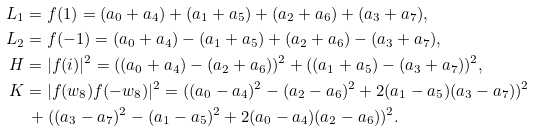Convert formula to latex. <formula><loc_0><loc_0><loc_500><loc_500>L _ { 1 } & = f ( 1 ) = ( a _ { 0 } + a _ { 4 } ) + ( a _ { 1 } + a _ { 5 } ) + ( a _ { 2 } + a _ { 6 } ) + ( a _ { 3 } + a _ { 7 } ) , \\ L _ { 2 } & = f ( - 1 ) = ( a _ { 0 } + a _ { 4 } ) - ( a _ { 1 } + a _ { 5 } ) + ( a _ { 2 } + a _ { 6 } ) - ( a _ { 3 } + a _ { 7 } ) , \\ H & = | f ( i ) | ^ { 2 } = ( ( a _ { 0 } + a _ { 4 } ) - ( a _ { 2 } + a _ { 6 } ) ) ^ { 2 } + ( ( a _ { 1 } + a _ { 5 } ) - ( a _ { 3 } + a _ { 7 } ) ) ^ { 2 } , \\ K & = | f ( w _ { 8 } ) f ( - w _ { 8 } ) | ^ { 2 } = ( ( a _ { 0 } - a _ { 4 } ) ^ { 2 } - ( a _ { 2 } - a _ { 6 } ) ^ { 2 } + 2 ( a _ { 1 } - a _ { 5 } ) ( a _ { 3 } - a _ { 7 } ) ) ^ { 2 } \\ & \, + ( ( a _ { 3 } - a _ { 7 } ) ^ { 2 } - ( a _ { 1 } - a _ { 5 } ) ^ { 2 } + 2 ( a _ { 0 } - a _ { 4 } ) ( a _ { 2 } - a _ { 6 } ) ) ^ { 2 } .</formula> 